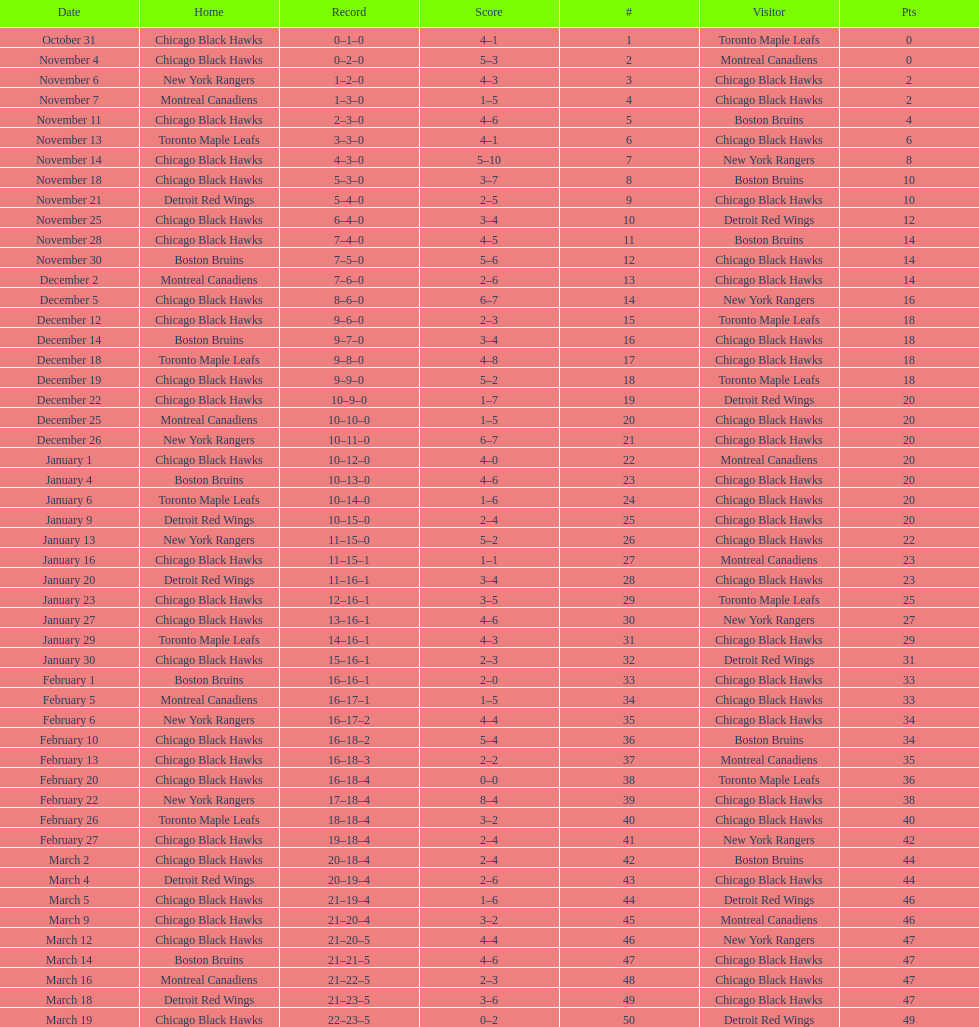Tell me the number of points the blackhawks had on march 4. 44. 